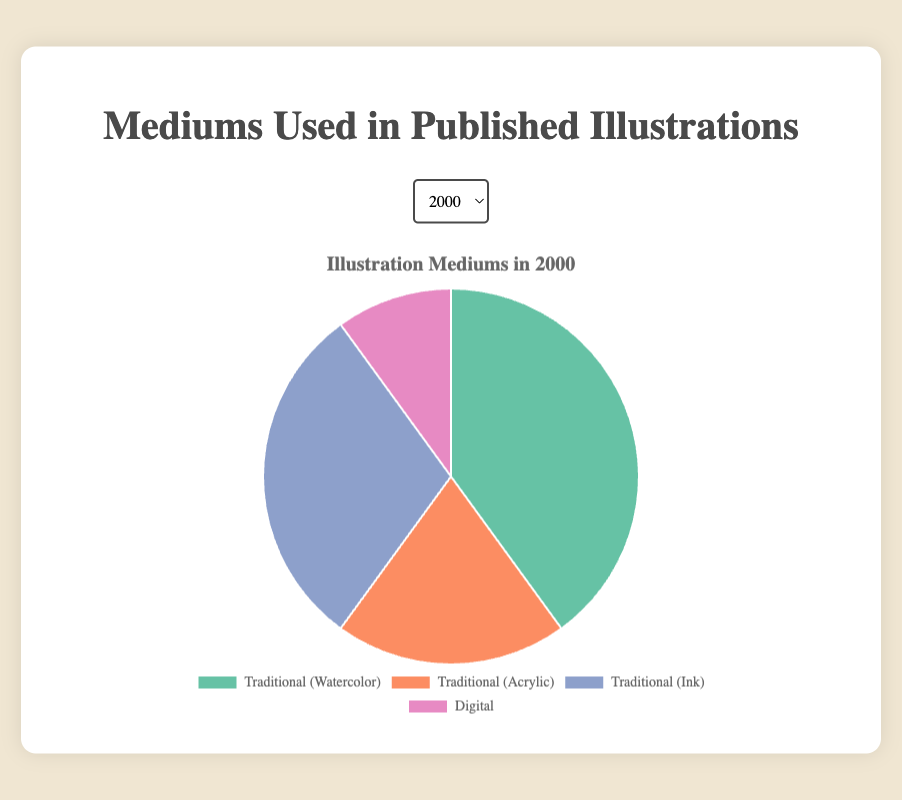What year had the highest percentage of Digital illustrations? Review the Digital section in each pie chart, noticing that 2023 has the largest slice, indicating the highest percentage of Digital illustrations.
Answer: 2023 How did the percentage of Traditional (Watercolor) illustrations change from 2000 to 2023? Compare the slices representing Traditional (Watercolor) illustrations in the pie charts for 2000 and 2023, noting the changes in size. In 2000, it was 40%, and in 2023, it dropped to 10%.
Answer: Decreased from 40% to 10% What is the trend in Traditional (Acrylic) illustration usage from 2000 to 2023? Examine the pie charts across all the years, focusing on the slices representing Traditional (Acrylic) illustrations. Notice the consistent decrease: 20% in 2000, 15% in 2005, 10% in 2010, 10% in 2015, 5% in 2020, and 5% in 2023.
Answer: Decreasing trend In 2015, which medium had a larger usage: Traditional (Ink) or Digital? Check the pie chart for 2015 and compare the sizes of the slices for Traditional (Ink) and Digital illustrations. Digital has a larger slice at 55%, while Traditional (Ink) is at 15%.
Answer: Digital What is the combined percentage of Traditional mediums (Watercolor, Acrylic, Ink) in 2010? Add the percentages of Traditional (Watercolor), Traditional (Acrylic), and Traditional (Ink) from the 2010 pie chart: \(30% + 10% + 20% = 60%\).
Answer: 60% Which medium had the most significant increase in percentage from 2000 to 2023? Compare each medium's percentage in 2000 and 2023. Digital illustrations increased the most, from 10% in 2000 to 80% in 2023.
Answer: Digital By how much did the percentage of Digital illustrations increase from 2010 to 2020? Find the percentage of Digital illustrations in both years and calculate the difference: \(75% - 40% = 35%\).
Answer: 35% In which year did Traditional (Watercolor) illustrations see the first decline below 20%? Observe the pie charts and detect the first year where Traditional (Watercolor) falls below 20%. It happens in 2015 when it drops to 20%.
Answer: 2015 What is the average percentage of Digital illustrations from 2000 to 2023? Add the percentages of Digital illustrations for each year and divide by the number of years: \((10 + 25 + 40 + 55 + 75 + 80) / 6 = 47.5%\).
Answer: 47.5% Which year had the closest percentage between Traditional (Acrylic) and Traditional (Ink) illustrations? Compare the pie charts for all years, focusing on the slices for Traditional (Acrylic) and Traditional (Ink). In 2023, both have the same percentage at 5%.
Answer: 2023 